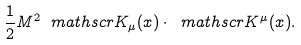Convert formula to latex. <formula><loc_0><loc_0><loc_500><loc_500>\frac { 1 } { 2 } M ^ { 2 } \ m a t h s c r { K } _ { \mu } ( x ) \cdot \ m a t h s c r { K } ^ { \mu } ( x ) .</formula> 